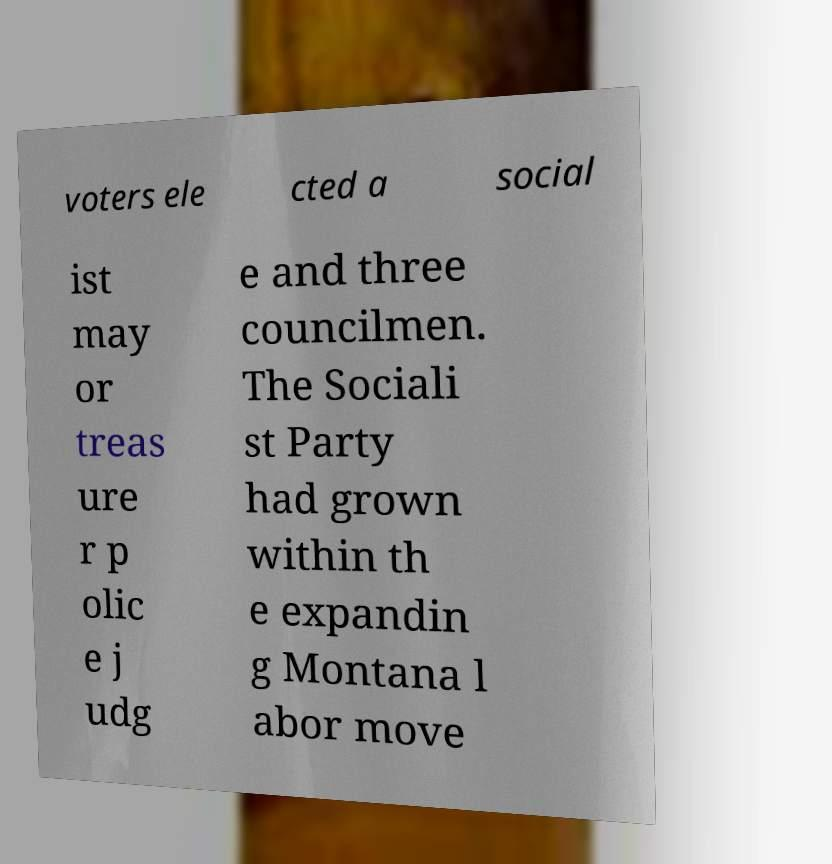There's text embedded in this image that I need extracted. Can you transcribe it verbatim? voters ele cted a social ist may or treas ure r p olic e j udg e and three councilmen. The Sociali st Party had grown within th e expandin g Montana l abor move 